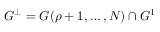Convert formula to latex. <formula><loc_0><loc_0><loc_500><loc_500>G ^ { \perp } = G ( \rho + 1 , \dots , N ) \cap G ^ { 1 }</formula> 